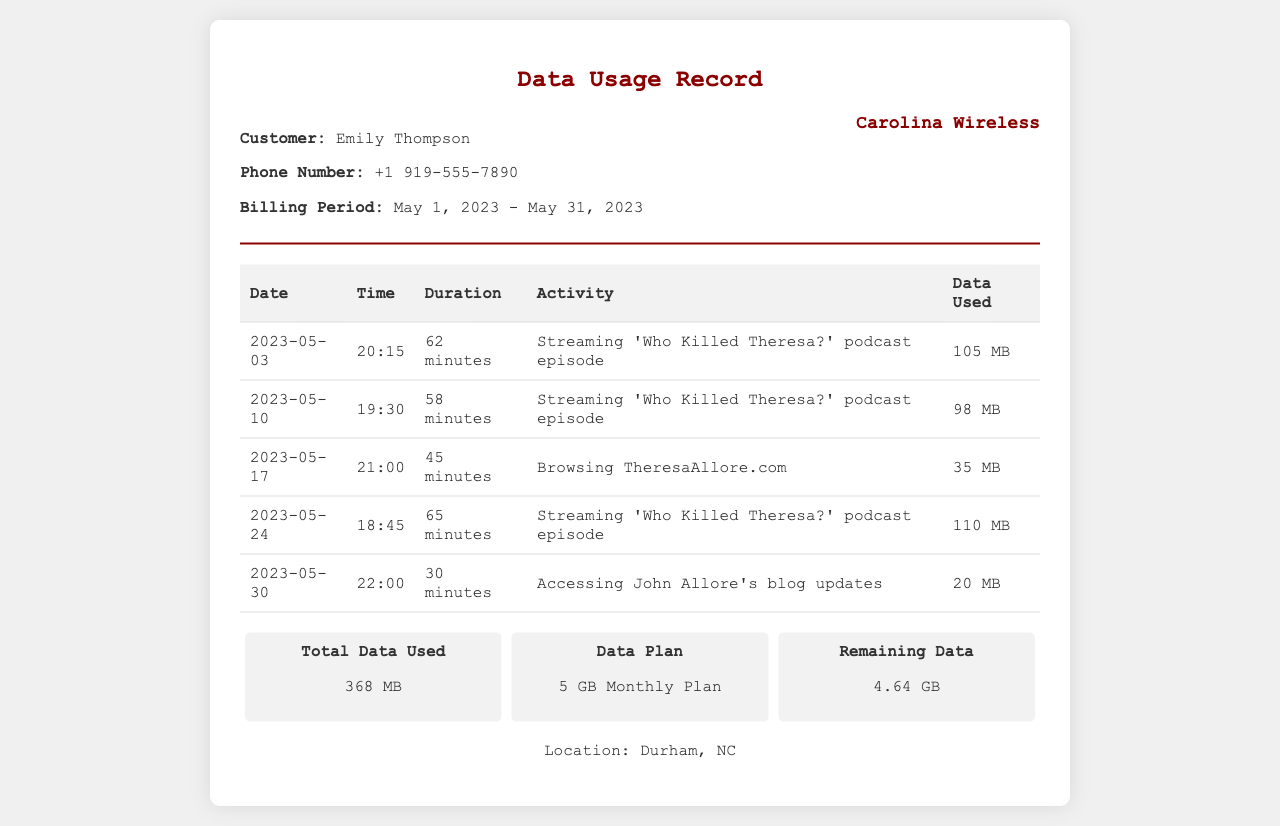What was the total data used for streaming John Allore's podcast episodes? The total data used for streaming is calculated by adding all the data related to the podcast episodes, which are 105 MB + 98 MB + 110 MB = 313 MB.
Answer: 313 MB When was the last activity for accessing John Allore's website? The last recorded activity for accessing John Allore's website is on May 30, 2023.
Answer: May 30, 2023 How many minutes was spent streaming the podcast on May 10, 2023? The document states that 58 minutes were spent streaming the podcast on that date.
Answer: 58 minutes What is the remaining data available in the plan? The remaining data is provided in the summary section of the document, stating that there is 4.64 GB remaining.
Answer: 4.64 GB What type of data plan does Emily Thompson have? The document specifies that Emily Thompson has a 5 GB Monthly Plan.
Answer: 5 GB Monthly Plan How many total activities are listed in the data usage record? The document lists a total of five separate activities in the usage table.
Answer: 5 activities Which episode of the podcast is mentioned most frequently? The repeated mention of 'Who Killed Theresa?' indicates it is the most frequently mentioned episode in the document.
Answer: 'Who Killed Theresa?' What was the data used for browsing TheresaAllore.com? The document states that the data used for browsing TheresaAllore.com was 35 MB.
Answer: 35 MB 